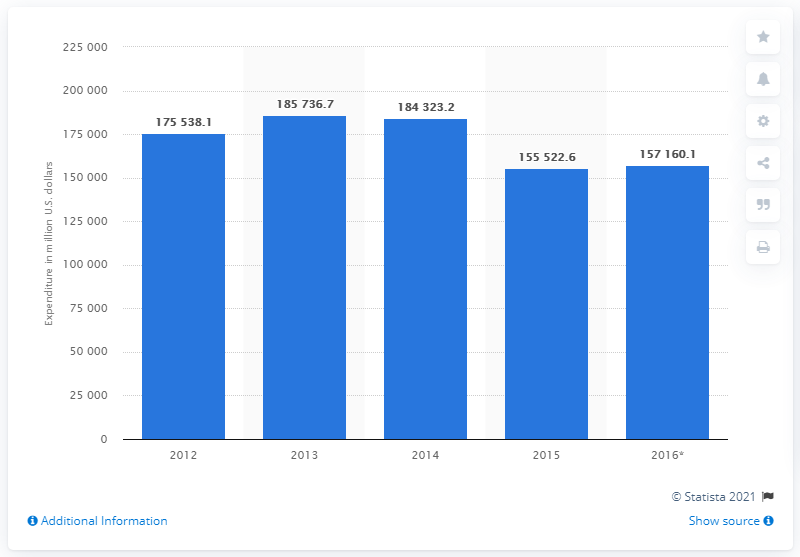Identify some key points in this picture. The projected expenditure on food in France in 2016 is expected to be 157,160.1. 